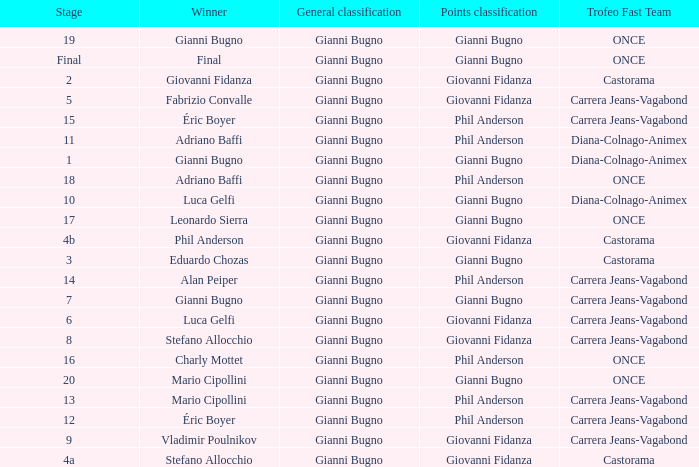Who is the trofeo fast team in stage 10? Diana-Colnago-Animex. 